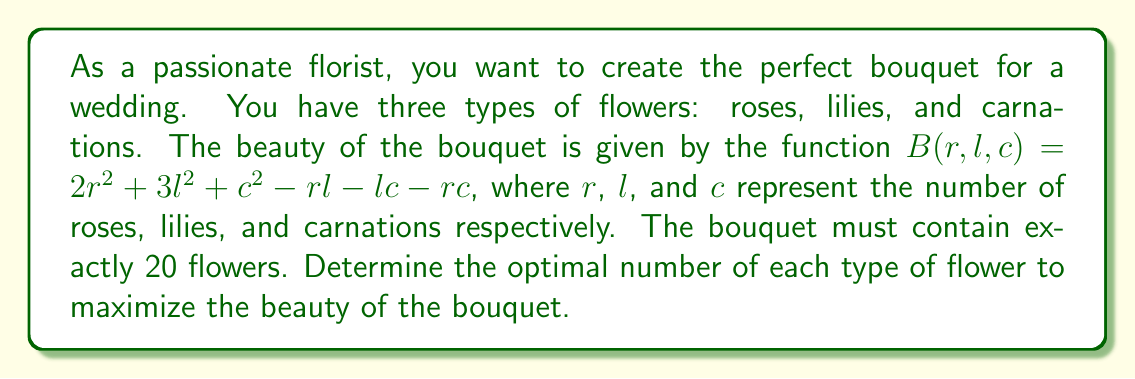Provide a solution to this math problem. To solve this problem, we'll use the method of Lagrange multipliers:

1) First, we set up the constraint equation:
   $g(r, l, c) = r + l + c - 20 = 0$

2) Now, we form the Lagrangian function:
   $L(r, l, c, \lambda) = B(r, l, c) - \lambda g(r, l, c)$
   $L(r, l, c, \lambda) = 2r^2 + 3l^2 + c^2 - rl - lc - rc - \lambda(r + l + c - 20)$

3) We take partial derivatives and set them equal to zero:
   $\frac{\partial L}{\partial r} = 4r - l - c - \lambda = 0$
   $\frac{\partial L}{\partial l} = 6l - r - c - \lambda = 0$
   $\frac{\partial L}{\partial c} = 2c - r - l - \lambda = 0$
   $\frac{\partial L}{\partial \lambda} = r + l + c - 20 = 0$

4) From these equations, we can deduce:
   $4r - l - c = 6l - r - c = 2c - r - l$

5) This implies:
   $4r - l - c = 6l - r - c$
   $5r = 7l$
   $r = \frac{7l}{5}$

   $6l - r - c = 2c - r - l$
   $5l = 3c$
   $l = \frac{3c}{5}$

6) Substituting these into the constraint equation:
   $\frac{7l}{5} + l + c = 20$
   $\frac{7l}{5} + \frac{5l}{5} + \frac{5c}{3} = 20$
   $\frac{12l}{5} + \frac{5c}{3} = 20$

7) Substituting $l = \frac{3c}{5}$:
   $\frac{12(\frac{3c}{5})}{5} + \frac{5c}{3} = 20$
   $\frac{36c}{25} + \frac{25c}{15} = 20$
   $\frac{108c + 125c}{75} = 20$
   $233c = 1500$
   $c = \frac{1500}{233} \approx 6.44$

8) Rounding to the nearest whole number (as we can't have fractional flowers):
   $c = 6$
   $l = \frac{3c}{5} = \frac{18}{5} \approx 4$
   $r = 20 - l - c = 10$
Answer: 10 roses, 4 lilies, 6 carnations 